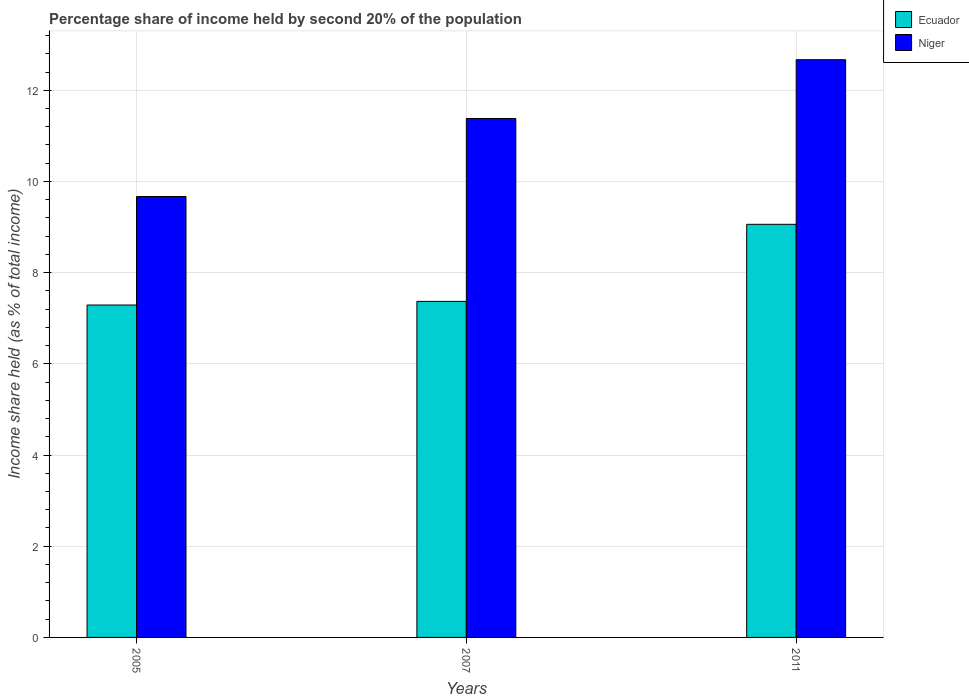How many groups of bars are there?
Your answer should be compact. 3. Are the number of bars per tick equal to the number of legend labels?
Offer a terse response. Yes. Are the number of bars on each tick of the X-axis equal?
Provide a short and direct response. Yes. How many bars are there on the 3rd tick from the left?
Offer a very short reply. 2. In how many cases, is the number of bars for a given year not equal to the number of legend labels?
Provide a succinct answer. 0. What is the share of income held by second 20% of the population in Niger in 2005?
Your answer should be very brief. 9.67. Across all years, what is the maximum share of income held by second 20% of the population in Niger?
Provide a short and direct response. 12.67. Across all years, what is the minimum share of income held by second 20% of the population in Ecuador?
Give a very brief answer. 7.29. In which year was the share of income held by second 20% of the population in Niger minimum?
Your response must be concise. 2005. What is the total share of income held by second 20% of the population in Niger in the graph?
Give a very brief answer. 33.72. What is the difference between the share of income held by second 20% of the population in Ecuador in 2005 and that in 2007?
Give a very brief answer. -0.08. What is the difference between the share of income held by second 20% of the population in Niger in 2011 and the share of income held by second 20% of the population in Ecuador in 2007?
Give a very brief answer. 5.3. What is the average share of income held by second 20% of the population in Niger per year?
Provide a short and direct response. 11.24. In the year 2005, what is the difference between the share of income held by second 20% of the population in Niger and share of income held by second 20% of the population in Ecuador?
Your answer should be very brief. 2.38. In how many years, is the share of income held by second 20% of the population in Ecuador greater than 6 %?
Offer a very short reply. 3. What is the ratio of the share of income held by second 20% of the population in Niger in 2005 to that in 2011?
Offer a very short reply. 0.76. Is the share of income held by second 20% of the population in Ecuador in 2005 less than that in 2007?
Ensure brevity in your answer.  Yes. What is the difference between the highest and the second highest share of income held by second 20% of the population in Niger?
Give a very brief answer. 1.29. What is the difference between the highest and the lowest share of income held by second 20% of the population in Ecuador?
Your response must be concise. 1.77. In how many years, is the share of income held by second 20% of the population in Niger greater than the average share of income held by second 20% of the population in Niger taken over all years?
Offer a terse response. 2. Is the sum of the share of income held by second 20% of the population in Niger in 2007 and 2011 greater than the maximum share of income held by second 20% of the population in Ecuador across all years?
Offer a very short reply. Yes. What does the 1st bar from the left in 2011 represents?
Give a very brief answer. Ecuador. What does the 1st bar from the right in 2007 represents?
Give a very brief answer. Niger. How many bars are there?
Provide a short and direct response. 6. Are all the bars in the graph horizontal?
Your answer should be very brief. No. How many years are there in the graph?
Your answer should be compact. 3. How are the legend labels stacked?
Give a very brief answer. Vertical. What is the title of the graph?
Offer a terse response. Percentage share of income held by second 20% of the population. Does "Zambia" appear as one of the legend labels in the graph?
Keep it short and to the point. No. What is the label or title of the Y-axis?
Keep it short and to the point. Income share held (as % of total income). What is the Income share held (as % of total income) of Ecuador in 2005?
Keep it short and to the point. 7.29. What is the Income share held (as % of total income) of Niger in 2005?
Provide a succinct answer. 9.67. What is the Income share held (as % of total income) of Ecuador in 2007?
Provide a short and direct response. 7.37. What is the Income share held (as % of total income) of Niger in 2007?
Give a very brief answer. 11.38. What is the Income share held (as % of total income) in Ecuador in 2011?
Your answer should be compact. 9.06. What is the Income share held (as % of total income) in Niger in 2011?
Offer a terse response. 12.67. Across all years, what is the maximum Income share held (as % of total income) of Ecuador?
Provide a succinct answer. 9.06. Across all years, what is the maximum Income share held (as % of total income) of Niger?
Provide a short and direct response. 12.67. Across all years, what is the minimum Income share held (as % of total income) of Ecuador?
Your answer should be compact. 7.29. Across all years, what is the minimum Income share held (as % of total income) of Niger?
Offer a terse response. 9.67. What is the total Income share held (as % of total income) in Ecuador in the graph?
Your answer should be very brief. 23.72. What is the total Income share held (as % of total income) in Niger in the graph?
Your answer should be very brief. 33.72. What is the difference between the Income share held (as % of total income) of Ecuador in 2005 and that in 2007?
Keep it short and to the point. -0.08. What is the difference between the Income share held (as % of total income) in Niger in 2005 and that in 2007?
Your answer should be very brief. -1.71. What is the difference between the Income share held (as % of total income) of Ecuador in 2005 and that in 2011?
Keep it short and to the point. -1.77. What is the difference between the Income share held (as % of total income) of Ecuador in 2007 and that in 2011?
Ensure brevity in your answer.  -1.69. What is the difference between the Income share held (as % of total income) in Niger in 2007 and that in 2011?
Your response must be concise. -1.29. What is the difference between the Income share held (as % of total income) of Ecuador in 2005 and the Income share held (as % of total income) of Niger in 2007?
Make the answer very short. -4.09. What is the difference between the Income share held (as % of total income) of Ecuador in 2005 and the Income share held (as % of total income) of Niger in 2011?
Offer a terse response. -5.38. What is the average Income share held (as % of total income) of Ecuador per year?
Offer a very short reply. 7.91. What is the average Income share held (as % of total income) of Niger per year?
Offer a very short reply. 11.24. In the year 2005, what is the difference between the Income share held (as % of total income) of Ecuador and Income share held (as % of total income) of Niger?
Keep it short and to the point. -2.38. In the year 2007, what is the difference between the Income share held (as % of total income) in Ecuador and Income share held (as % of total income) in Niger?
Provide a succinct answer. -4.01. In the year 2011, what is the difference between the Income share held (as % of total income) in Ecuador and Income share held (as % of total income) in Niger?
Ensure brevity in your answer.  -3.61. What is the ratio of the Income share held (as % of total income) of Ecuador in 2005 to that in 2007?
Offer a terse response. 0.99. What is the ratio of the Income share held (as % of total income) of Niger in 2005 to that in 2007?
Ensure brevity in your answer.  0.85. What is the ratio of the Income share held (as % of total income) of Ecuador in 2005 to that in 2011?
Provide a succinct answer. 0.8. What is the ratio of the Income share held (as % of total income) in Niger in 2005 to that in 2011?
Your response must be concise. 0.76. What is the ratio of the Income share held (as % of total income) in Ecuador in 2007 to that in 2011?
Give a very brief answer. 0.81. What is the ratio of the Income share held (as % of total income) in Niger in 2007 to that in 2011?
Your answer should be very brief. 0.9. What is the difference between the highest and the second highest Income share held (as % of total income) in Ecuador?
Your answer should be compact. 1.69. What is the difference between the highest and the second highest Income share held (as % of total income) in Niger?
Give a very brief answer. 1.29. What is the difference between the highest and the lowest Income share held (as % of total income) of Ecuador?
Keep it short and to the point. 1.77. 